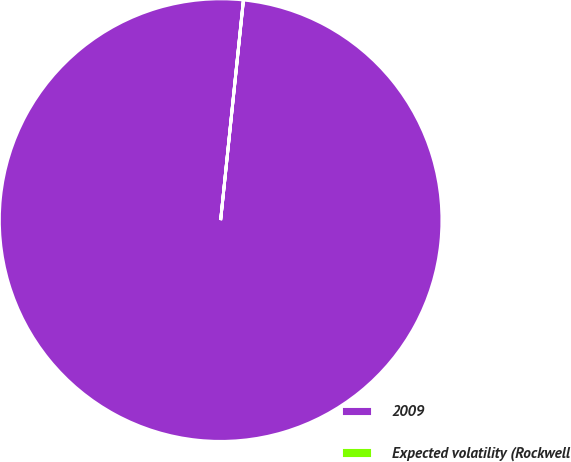Convert chart. <chart><loc_0><loc_0><loc_500><loc_500><pie_chart><fcel>2009<fcel>Expected volatility (Rockwell<nl><fcel>99.99%<fcel>0.01%<nl></chart> 